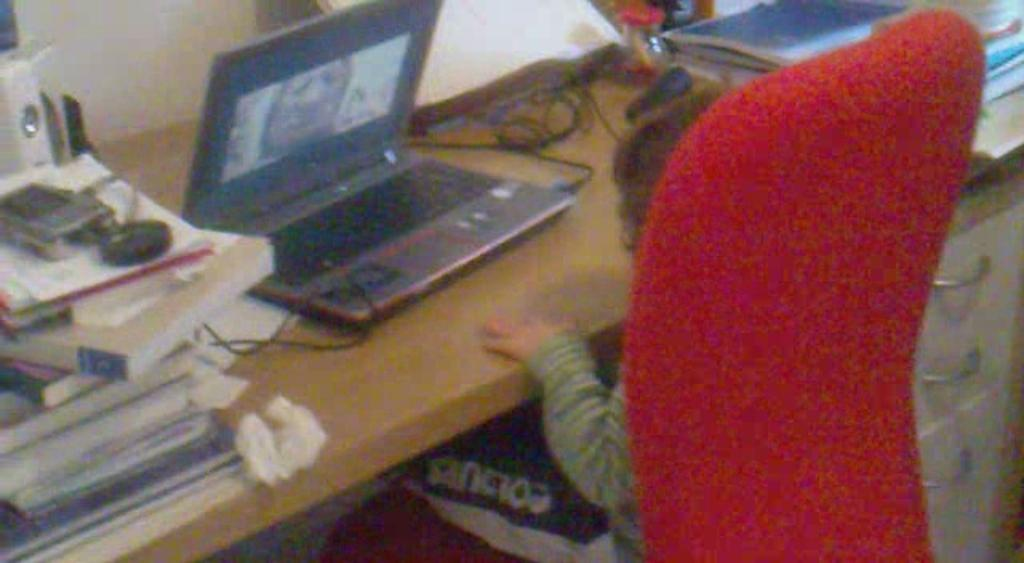What is the main piece of furniture in the image? There is a table in the image. What items can be seen on the table? There are books, a laptop, and wires on the table. What is the child doing in the image? The child is sitting on a chair in front of the table. What type of storage is present in the image? There are racks present in the image. How many oranges are being sold on the laptop in the image? There are no oranges or any indication of a sale on the laptop in the image. What type of hen can be seen on the racks in the image? There are no hens present in the image; only books, a laptop, wires, a child, and racks can be seen. 